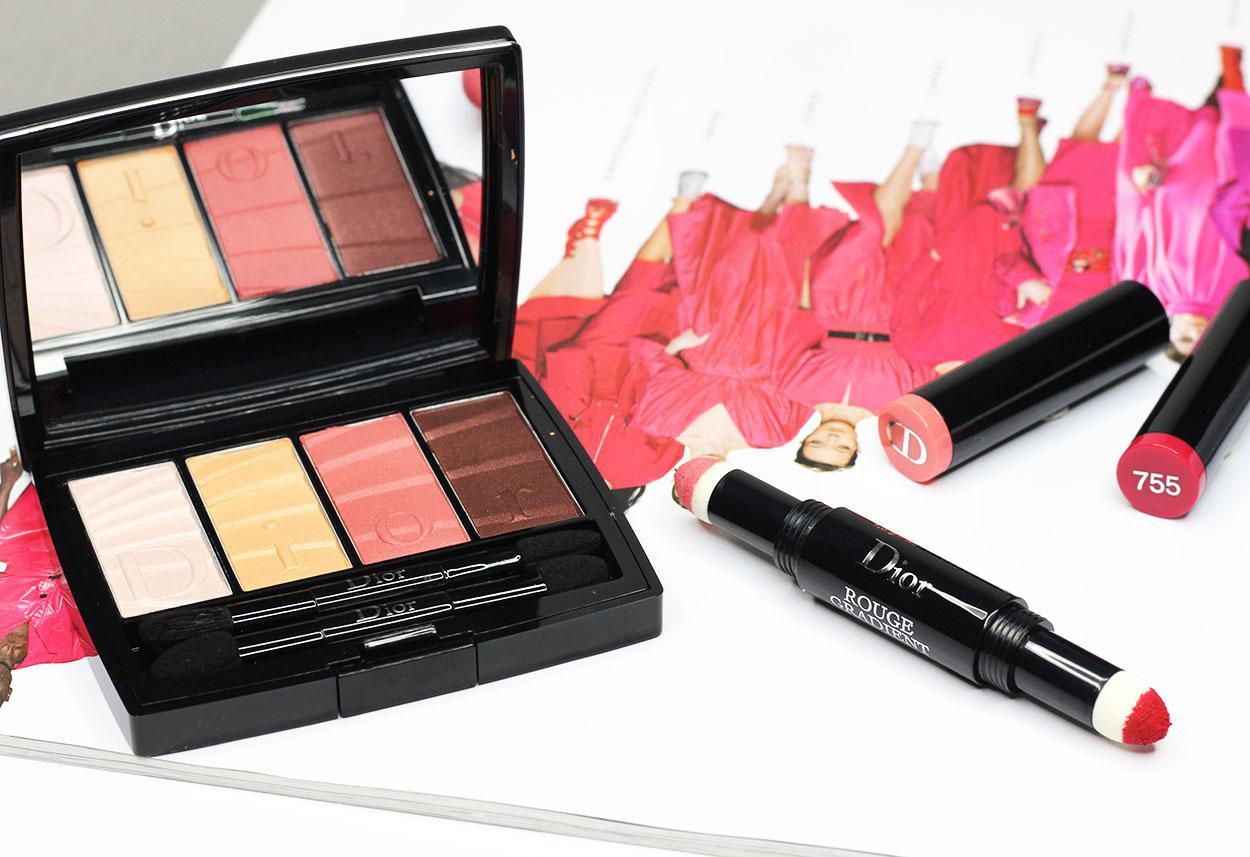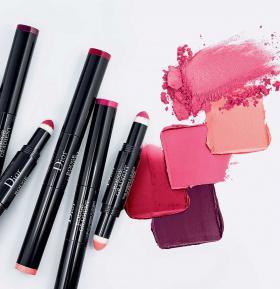The first image is the image on the left, the second image is the image on the right. Considering the images on both sides, is "Each image includes an unlidded double-sided lip makeup with a marker-type tip on each end of a stick." valid? Answer yes or no. Yes. The first image is the image on the left, the second image is the image on the right. Assess this claim about the two images: "The makeup in the left image is photographed against a pure white background with no decoration on it.". Correct or not? Answer yes or no. No. 